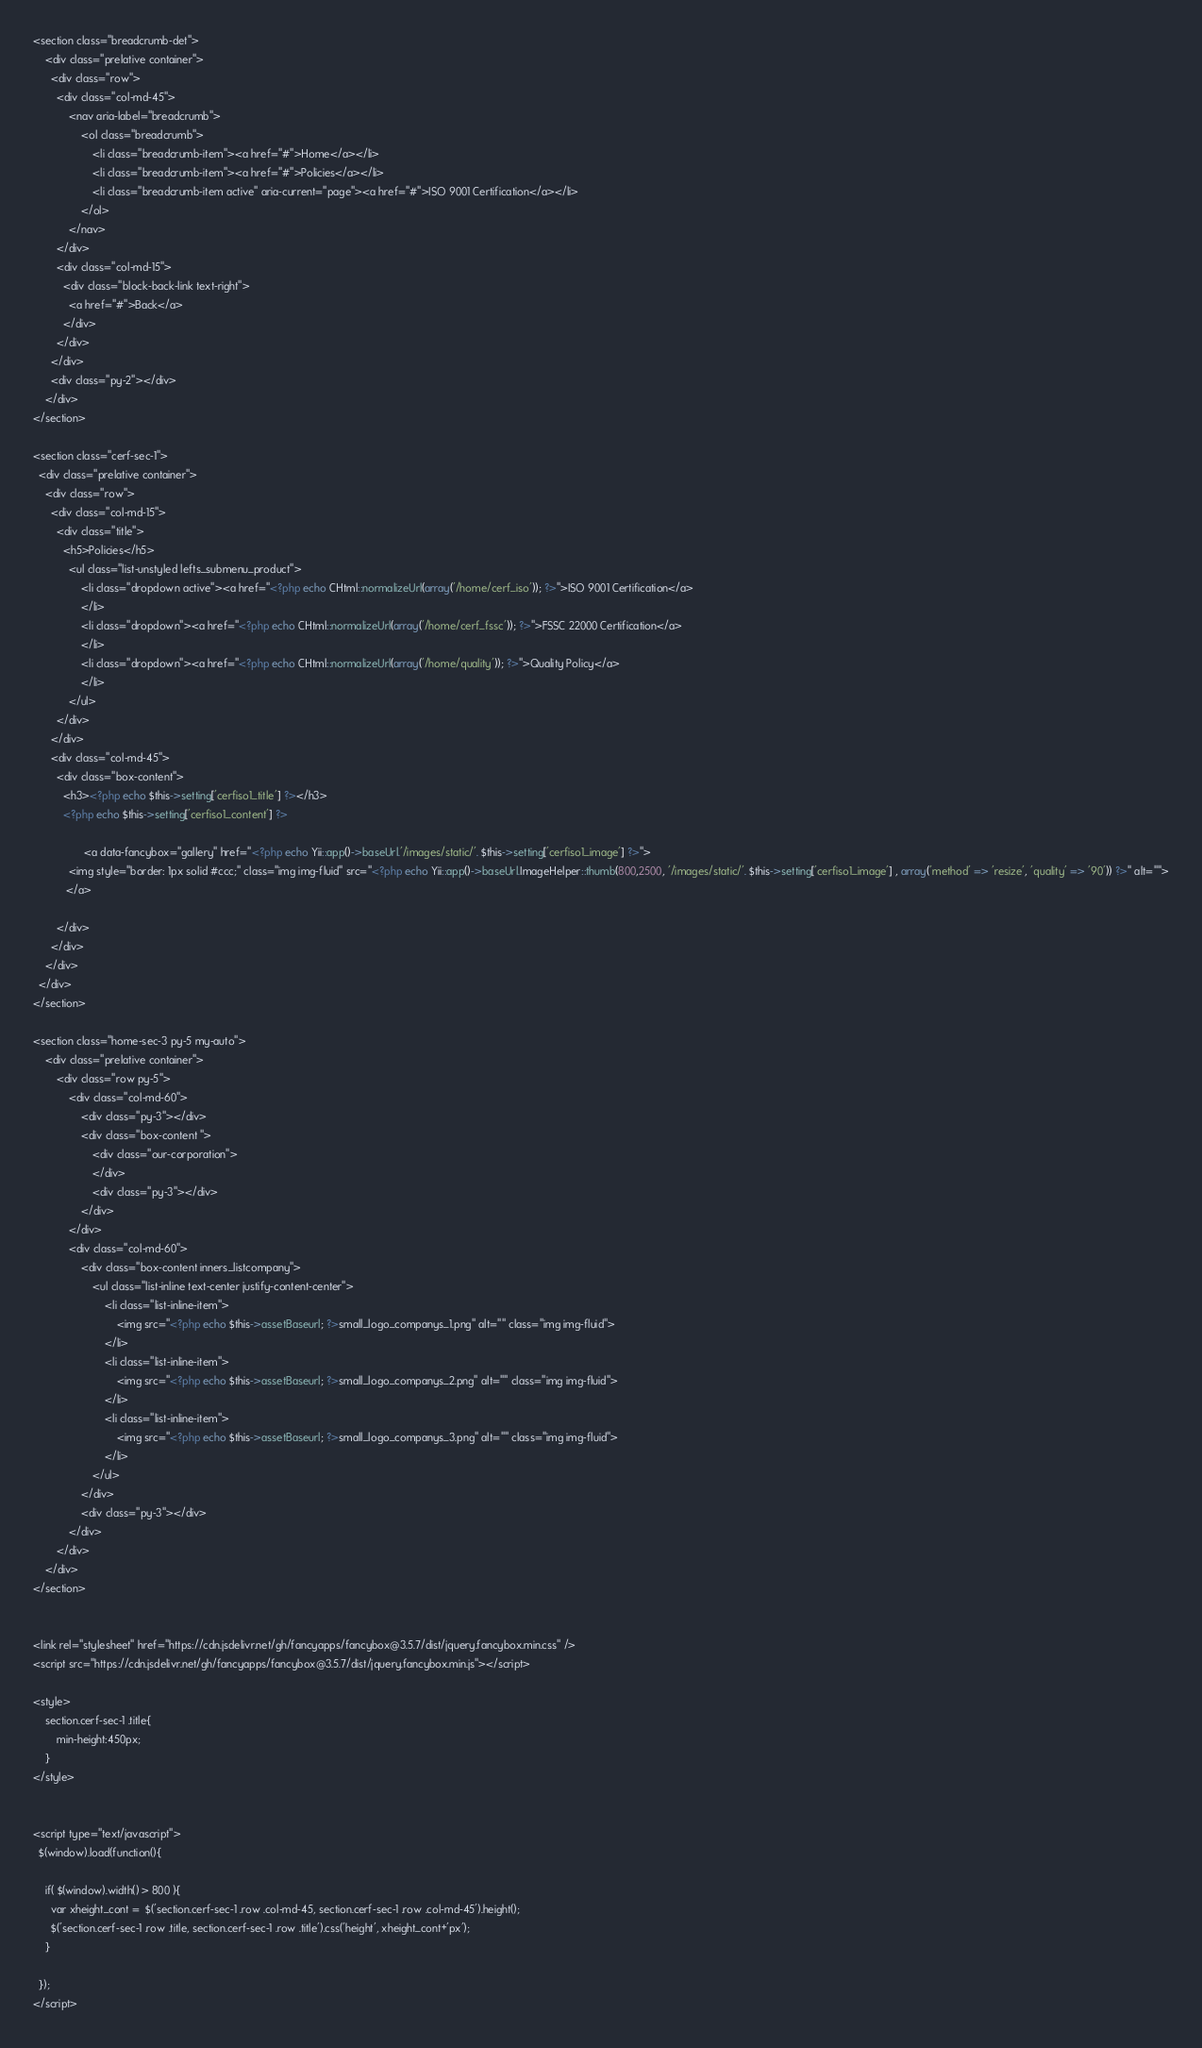<code> <loc_0><loc_0><loc_500><loc_500><_PHP_><section class="breadcrumb-det">
    <div class="prelative container">
      <div class="row">
        <div class="col-md-45">
            <nav aria-label="breadcrumb">
                <ol class="breadcrumb">
					<li class="breadcrumb-item"><a href="#">Home</a></li>
					<li class="breadcrumb-item"><a href="#">Policies</a></li>
                    <li class="breadcrumb-item active" aria-current="page"><a href="#">ISO 9001 Certification</a></li>
                </ol>
            </nav>
        </div>
        <div class="col-md-15">
          <div class="block-back-link text-right">
            <a href="#">Back</a>
          </div>
        </div>
      </div>
      <div class="py-2"></div>
    </div>
</section>

<section class="cerf-sec-1">
  <div class="prelative container">
    <div class="row">
      <div class="col-md-15">
        <div class="title">
          <h5>Policies</h5>
            <ul class="list-unstyled lefts_submenu_product">
            	<li class="dropdown active"><a href="<?php echo CHtml::normalizeUrl(array('/home/cerf_iso')); ?>">ISO 9001 Certification</a>
            	</li>
            	<li class="dropdown"><a href="<?php echo CHtml::normalizeUrl(array('/home/cerf_fssc')); ?>">FSSC 22000 Certification</a>
            	</li>
            	<li class="dropdown"><a href="<?php echo CHtml::normalizeUrl(array('/home/quality')); ?>">Quality Policy</a>
            	</li>
            </ul>
        </div>
      </div>
      <div class="col-md-45">
        <div class="box-content">
          <h3><?php echo $this->setting['cerfiso1_title'] ?></h3>
          <?php echo $this->setting['cerfiso1_content'] ?>

			     <a data-fancybox="gallery" href="<?php echo Yii::app()->baseUrl.'/images/static/'. $this->setting['cerfiso1_image'] ?>">
            <img style="border: 1px solid #ccc;" class="img img-fluid" src="<?php echo Yii::app()->baseUrl.ImageHelper::thumb(800,2500, '/images/static/'. $this->setting['cerfiso1_image'] , array('method' => 'resize', 'quality' => '90')) ?>" alt="">
           </a>

        </div>
      </div>
    </div>
  </div>
</section>

<section class="home-sec-3 py-5 my-auto">
    <div class="prelative container">
        <div class="row py-5">
            <div class="col-md-60">
                <div class="py-3"></div>
                <div class="box-content ">
                    <div class="our-corporation">
                    </div>
                    <div class="py-3"></div>
                </div>
            </div>
            <div class="col-md-60">
                <div class="box-content inners_listcompany">
                    <ul class="list-inline text-center justify-content-center">
                        <li class="list-inline-item">
                            <img src="<?php echo $this->assetBaseurl; ?>small_logo_companys_1.png" alt="" class="img img-fluid">
                        </li>
                        <li class="list-inline-item">
                            <img src="<?php echo $this->assetBaseurl; ?>small_logo_companys_2.png" alt="" class="img img-fluid">
                        </li>
                        <li class="list-inline-item">
                            <img src="<?php echo $this->assetBaseurl; ?>small_logo_companys_3.png" alt="" class="img img-fluid">
                        </li>
                    </ul>
                </div>
                <div class="py-3"></div>
            </div>
        </div>
    </div>
</section>


<link rel="stylesheet" href="https://cdn.jsdelivr.net/gh/fancyapps/fancybox@3.5.7/dist/jquery.fancybox.min.css" />
<script src="https://cdn.jsdelivr.net/gh/fancyapps/fancybox@3.5.7/dist/jquery.fancybox.min.js"></script>

<style>
    section.cerf-sec-1 .title{
        min-height:450px;
    }
</style>


<script type="text/javascript">
  $(window).load(function(){
    
    if( $(window).width() > 800 ){
      var xheight_cont =  $('section.cerf-sec-1 .row .col-md-45, section.cerf-sec-1 .row .col-md-45').height();
      $('section.cerf-sec-1 .row .title, section.cerf-sec-1 .row .title').css('height', xheight_cont+'px');
    } 

  });
</script></code> 